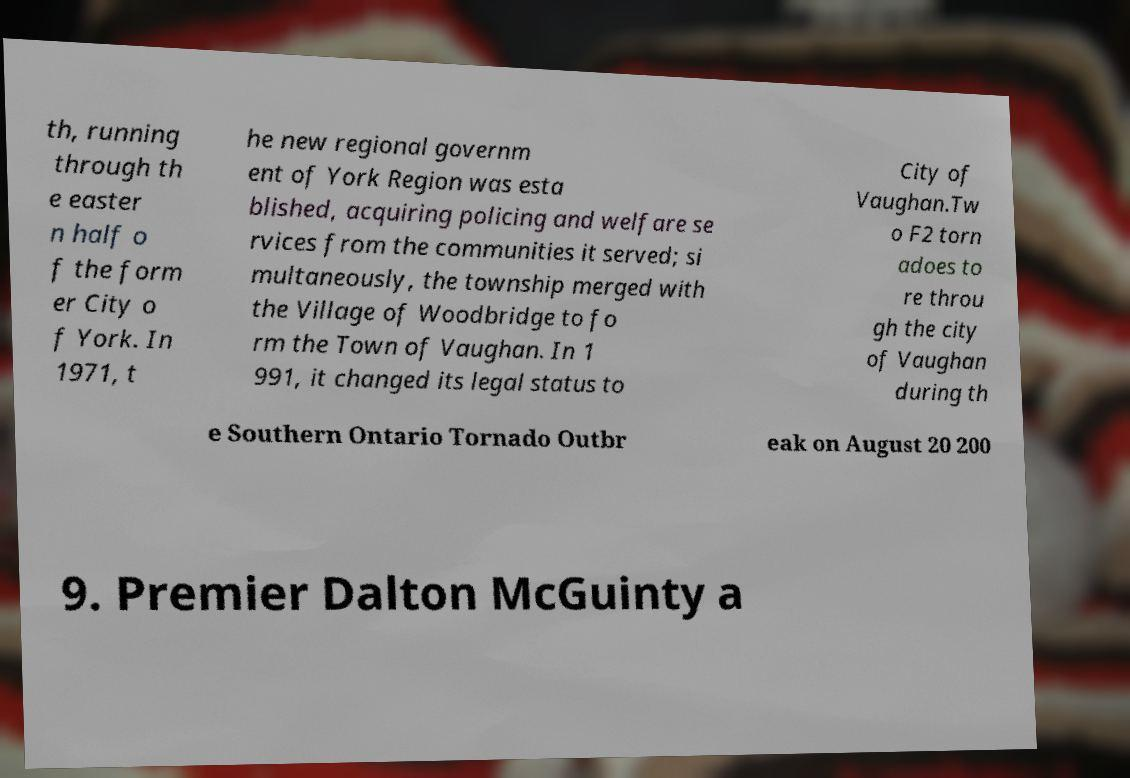Please identify and transcribe the text found in this image. th, running through th e easter n half o f the form er City o f York. In 1971, t he new regional governm ent of York Region was esta blished, acquiring policing and welfare se rvices from the communities it served; si multaneously, the township merged with the Village of Woodbridge to fo rm the Town of Vaughan. In 1 991, it changed its legal status to City of Vaughan.Tw o F2 torn adoes to re throu gh the city of Vaughan during th e Southern Ontario Tornado Outbr eak on August 20 200 9. Premier Dalton McGuinty a 